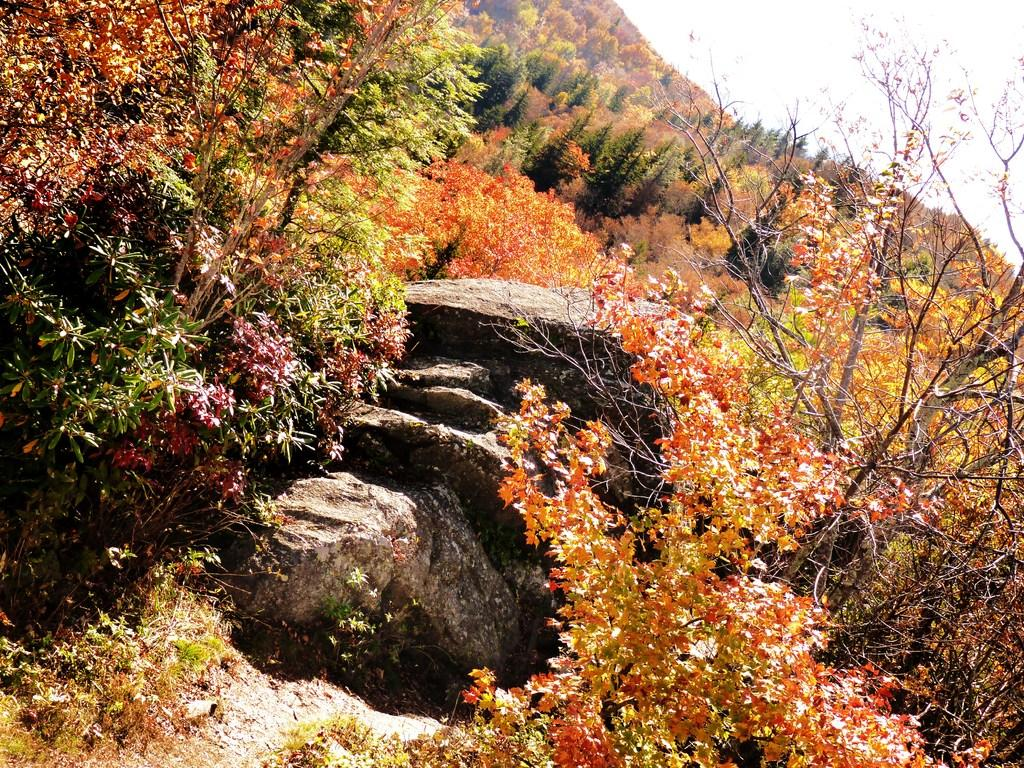What geographical feature is present in the image? There is a hill in the image. What can be seen on the hill? There are colorful trees on the hill. What part of the sky is visible in the image? The sky is visible in the top right of the image. What type of straw is being used to conduct a science experiment in the image? There is no straw or science experiment present in the image. 